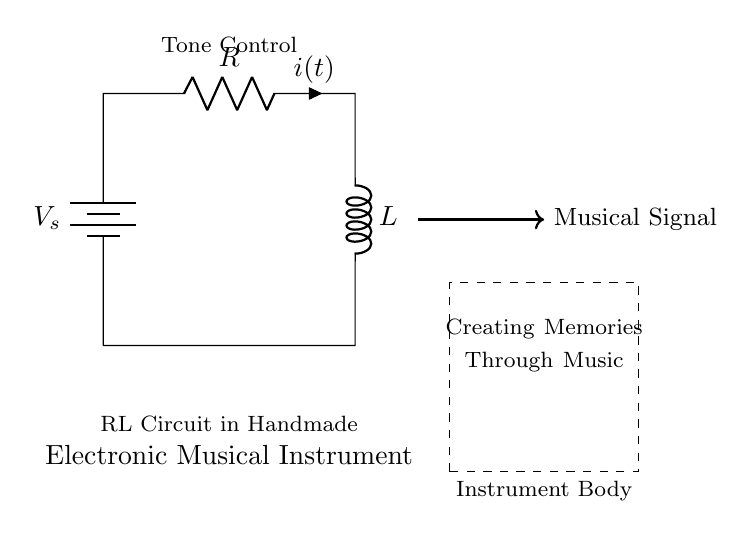What components are present in this circuit? The circuit diagram includes a battery, a resistor, and an inductor. These components are distinctly labeled.
Answer: battery, resistor, inductor What is the labeled current in the circuit? The current flowing through the circuit is labeled as "i(t)", indicating that it is a function of time. This label is located next to the resistor in the diagram.
Answer: i(t) What does the dashed rectangle signify? The dashed rectangle encompasses the area labeled "Instrument Body," indicating that this part of the circuit diagram represents the physical enclosure or casing of the handmade electronic musical instrument.
Answer: Instrument Body What role does the resistor play in this RL circuit? The resistor limits the current in the circuit. It creates a voltage drop, which influences how the circuit responds to changes in power and affects the overall sound generation from the instrument.
Answer: Limits current How does the inductor affect the circuit dynamics? The inductor stores energy in the magnetic field during current flow and releases it when the current reduces, creating a delay in current change. This property makes RL circuits suitable for producing specific musical effects, such as smoothing out audio signals.
Answer: Stores energy What is the purpose of the voltage source in this circuit? The voltage source, labeled "V_s", provides the electrical energy necessary to power the circuit, allowing the other components to function and create musical sounds.
Answer: Powers circuit 